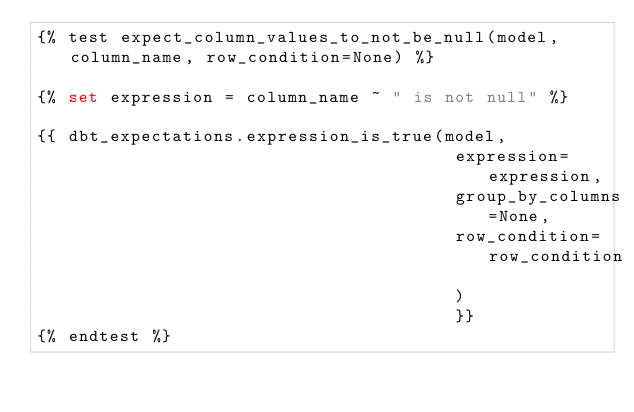Convert code to text. <code><loc_0><loc_0><loc_500><loc_500><_SQL_>{% test expect_column_values_to_not_be_null(model, column_name, row_condition=None) %}

{% set expression = column_name ~ " is not null" %}

{{ dbt_expectations.expression_is_true(model,
                                        expression=expression,
                                        group_by_columns=None,
                                        row_condition=row_condition
                                        )
                                        }}
{% endtest %}
</code> 